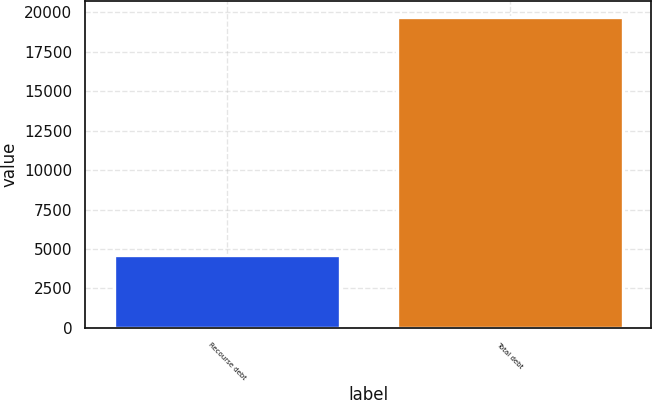Convert chart. <chart><loc_0><loc_0><loc_500><loc_500><bar_chart><fcel>Recourse debt<fcel>Total debt<nl><fcel>4612<fcel>19733<nl></chart> 